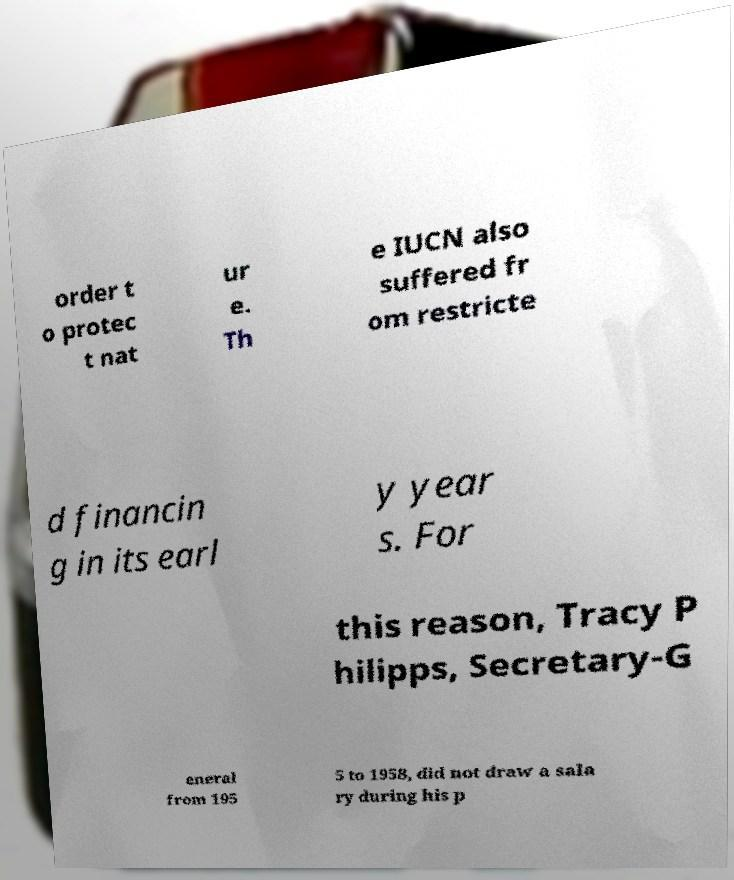Can you accurately transcribe the text from the provided image for me? order t o protec t nat ur e. Th e IUCN also suffered fr om restricte d financin g in its earl y year s. For this reason, Tracy P hilipps, Secretary-G eneral from 195 5 to 1958, did not draw a sala ry during his p 